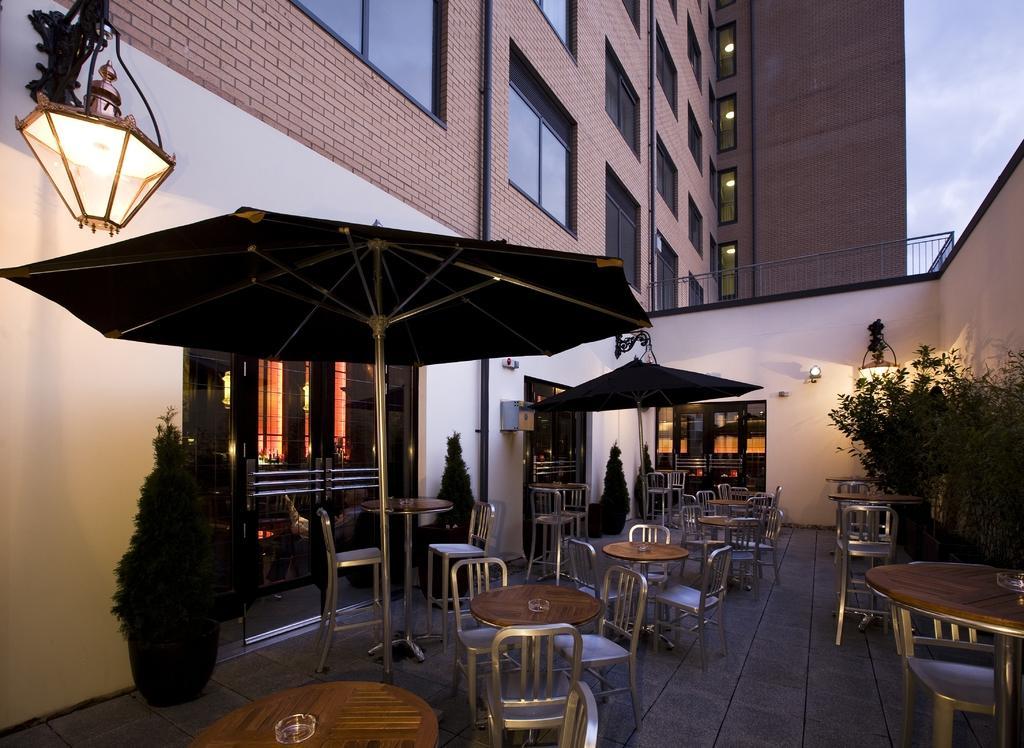Could you give a brief overview of what you see in this image? This picture might be taken in a restaurant, in this picture in the background there are some buildings and in the foreground there are umbrellas, tables, chairs and some plants. On the left side there is one lamp, in the background there is a glass door. At the bottom there is a floor. 